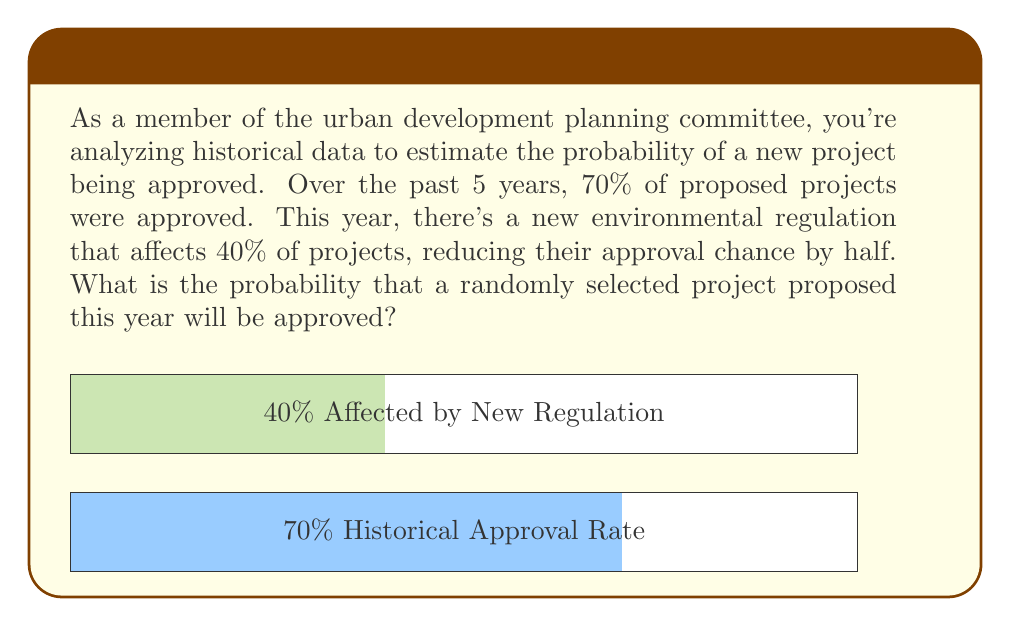Give your solution to this math problem. Let's approach this step-by-step using Bayesian reasoning:

1) Let A be the event that a project is approved, and R be the event that a project is affected by the new regulation.

2) We're given:
   P(A) = 0.70 (historical approval rate)
   P(R) = 0.40 (probability of being affected by new regulation)
   P(A|R) = 0.5 * P(A) = 0.35 (approval rate if affected by regulation)

3) We need to find P(A'), the new probability of approval. We can use the law of total probability:

   $$P(A') = P(A|R) * P(R) + P(A|not R) * P(not R)$$

4) We know P(A|R) and P(R). We need to find P(A|not R) and P(not R):
   P(not R) = 1 - P(R) = 1 - 0.40 = 0.60
   
   For P(A|not R), we can assume it remains the same as the historical rate:
   P(A|not R) = 0.70

5) Now we can plug these values into our equation:

   $$P(A') = 0.35 * 0.40 + 0.70 * 0.60$$

6) Calculating:
   $$P(A') = 0.14 + 0.42 = 0.56$$

Therefore, the probability that a randomly selected project proposed this year will be approved is 0.56 or 56%.
Answer: 0.56 